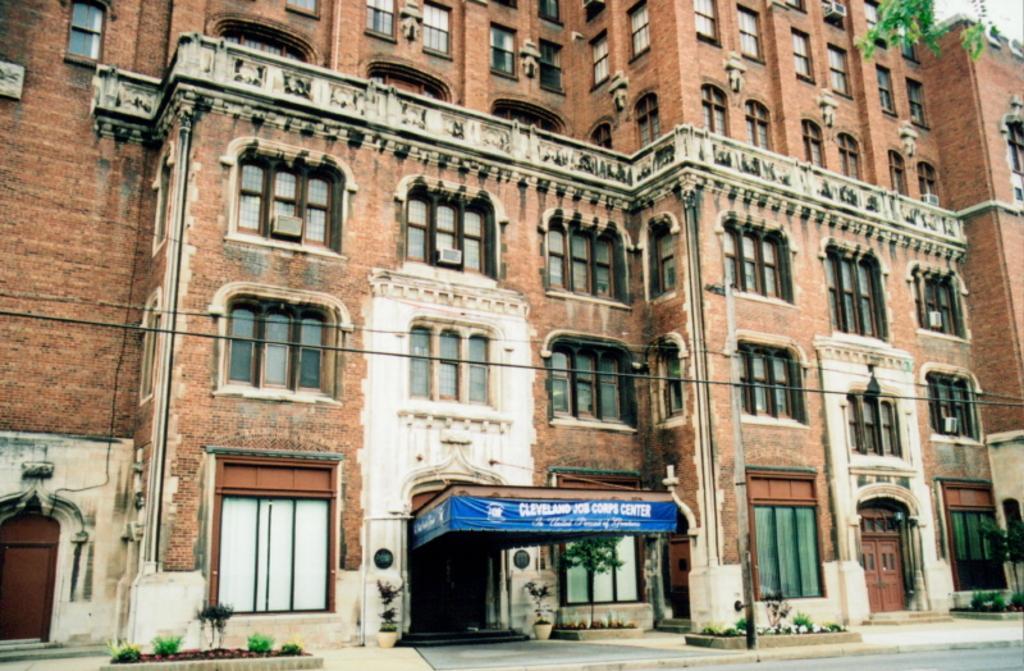In one or two sentences, can you explain what this image depicts? In this image we can see the building with the windows and also the doors. We can also see the plants, pole, wires, stairs, path and also the road. 